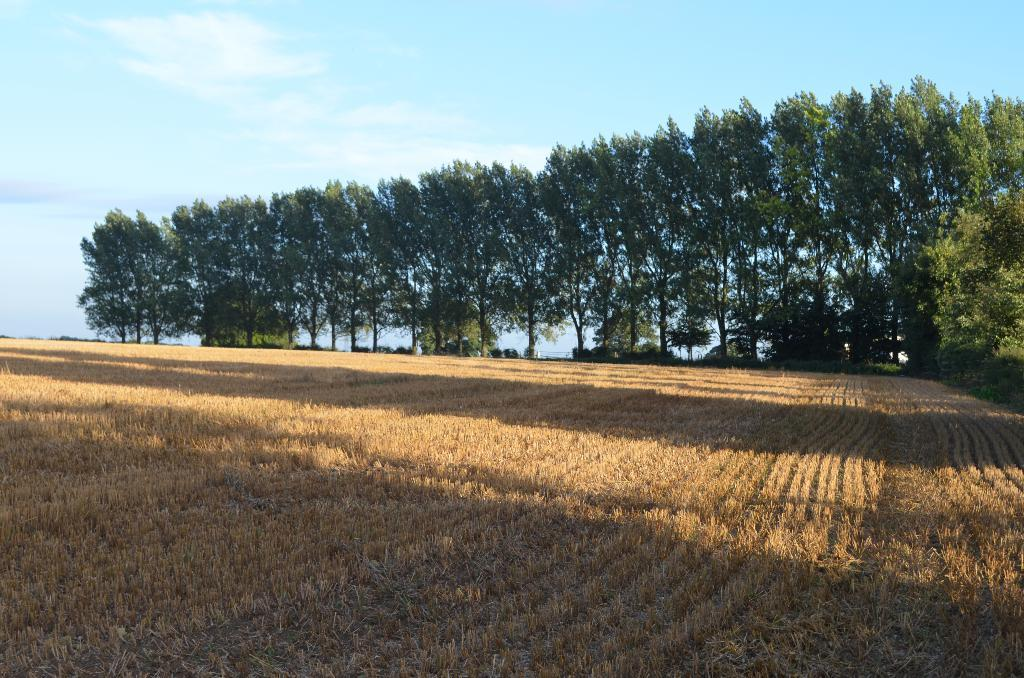Where was the image taken? The image was clicked outside the city. What can be seen in the foreground of the image? There are crops in the foreground of the image. What is visible in the background of the image? There is a sky, plants, and trees visible in the background of the image. How many beds can be seen in the image? There are no beds present in the image. What type of ear is visible on the crops in the image? Crops do not have ears; the term "ear" is typically used to describe a part of corn or other similar plants, but the image does not specify the type of crops. 